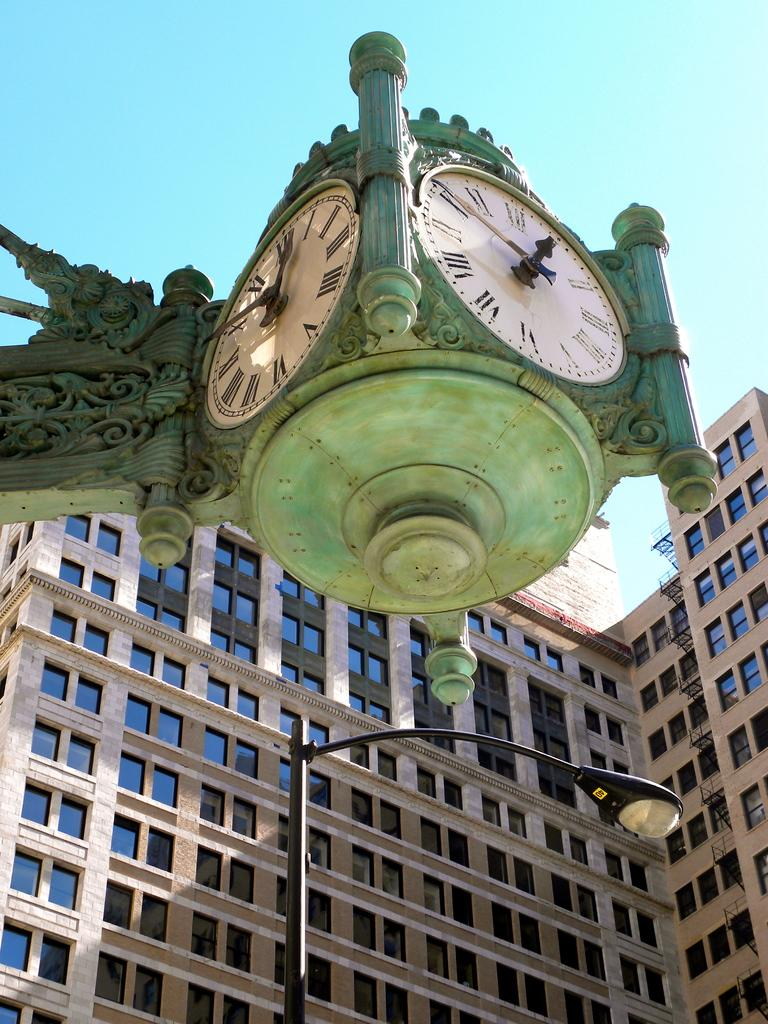<image>
Write a terse but informative summary of the picture. a square hanging clock on the corner says that it is 12:50 